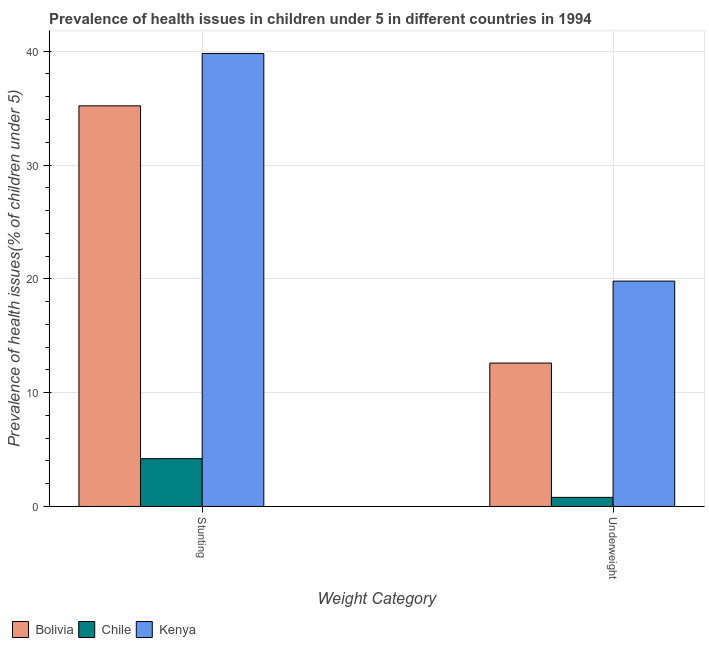How many different coloured bars are there?
Your answer should be compact. 3. How many groups of bars are there?
Give a very brief answer. 2. Are the number of bars per tick equal to the number of legend labels?
Your response must be concise. Yes. How many bars are there on the 2nd tick from the left?
Make the answer very short. 3. How many bars are there on the 2nd tick from the right?
Your response must be concise. 3. What is the label of the 1st group of bars from the left?
Provide a succinct answer. Stunting. What is the percentage of stunted children in Chile?
Keep it short and to the point. 4.2. Across all countries, what is the maximum percentage of stunted children?
Your answer should be very brief. 39.8. Across all countries, what is the minimum percentage of underweight children?
Make the answer very short. 0.8. In which country was the percentage of stunted children maximum?
Offer a very short reply. Kenya. What is the total percentage of underweight children in the graph?
Give a very brief answer. 33.2. What is the difference between the percentage of stunted children in Chile and that in Bolivia?
Keep it short and to the point. -31. What is the difference between the percentage of underweight children in Kenya and the percentage of stunted children in Chile?
Provide a succinct answer. 15.6. What is the average percentage of underweight children per country?
Give a very brief answer. 11.07. What is the difference between the percentage of stunted children and percentage of underweight children in Bolivia?
Ensure brevity in your answer.  22.6. In how many countries, is the percentage of stunted children greater than 28 %?
Make the answer very short. 2. What is the ratio of the percentage of stunted children in Kenya to that in Chile?
Your answer should be compact. 9.48. What does the 3rd bar from the left in Underweight represents?
Keep it short and to the point. Kenya. What is the difference between two consecutive major ticks on the Y-axis?
Keep it short and to the point. 10. Does the graph contain any zero values?
Your answer should be very brief. No. Does the graph contain grids?
Give a very brief answer. Yes. Where does the legend appear in the graph?
Provide a short and direct response. Bottom left. How many legend labels are there?
Your answer should be compact. 3. What is the title of the graph?
Your answer should be compact. Prevalence of health issues in children under 5 in different countries in 1994. What is the label or title of the X-axis?
Provide a short and direct response. Weight Category. What is the label or title of the Y-axis?
Give a very brief answer. Prevalence of health issues(% of children under 5). What is the Prevalence of health issues(% of children under 5) in Bolivia in Stunting?
Give a very brief answer. 35.2. What is the Prevalence of health issues(% of children under 5) of Chile in Stunting?
Offer a terse response. 4.2. What is the Prevalence of health issues(% of children under 5) in Kenya in Stunting?
Keep it short and to the point. 39.8. What is the Prevalence of health issues(% of children under 5) in Bolivia in Underweight?
Your answer should be very brief. 12.6. What is the Prevalence of health issues(% of children under 5) of Chile in Underweight?
Your response must be concise. 0.8. What is the Prevalence of health issues(% of children under 5) of Kenya in Underweight?
Your response must be concise. 19.8. Across all Weight Category, what is the maximum Prevalence of health issues(% of children under 5) of Bolivia?
Keep it short and to the point. 35.2. Across all Weight Category, what is the maximum Prevalence of health issues(% of children under 5) in Chile?
Your response must be concise. 4.2. Across all Weight Category, what is the maximum Prevalence of health issues(% of children under 5) of Kenya?
Ensure brevity in your answer.  39.8. Across all Weight Category, what is the minimum Prevalence of health issues(% of children under 5) of Bolivia?
Give a very brief answer. 12.6. Across all Weight Category, what is the minimum Prevalence of health issues(% of children under 5) in Chile?
Your answer should be compact. 0.8. Across all Weight Category, what is the minimum Prevalence of health issues(% of children under 5) of Kenya?
Keep it short and to the point. 19.8. What is the total Prevalence of health issues(% of children under 5) in Bolivia in the graph?
Offer a terse response. 47.8. What is the total Prevalence of health issues(% of children under 5) of Chile in the graph?
Provide a short and direct response. 5. What is the total Prevalence of health issues(% of children under 5) of Kenya in the graph?
Provide a succinct answer. 59.6. What is the difference between the Prevalence of health issues(% of children under 5) of Bolivia in Stunting and that in Underweight?
Give a very brief answer. 22.6. What is the difference between the Prevalence of health issues(% of children under 5) of Bolivia in Stunting and the Prevalence of health issues(% of children under 5) of Chile in Underweight?
Provide a succinct answer. 34.4. What is the difference between the Prevalence of health issues(% of children under 5) of Bolivia in Stunting and the Prevalence of health issues(% of children under 5) of Kenya in Underweight?
Offer a very short reply. 15.4. What is the difference between the Prevalence of health issues(% of children under 5) in Chile in Stunting and the Prevalence of health issues(% of children under 5) in Kenya in Underweight?
Your answer should be compact. -15.6. What is the average Prevalence of health issues(% of children under 5) in Bolivia per Weight Category?
Provide a short and direct response. 23.9. What is the average Prevalence of health issues(% of children under 5) of Kenya per Weight Category?
Offer a terse response. 29.8. What is the difference between the Prevalence of health issues(% of children under 5) in Chile and Prevalence of health issues(% of children under 5) in Kenya in Stunting?
Ensure brevity in your answer.  -35.6. What is the difference between the Prevalence of health issues(% of children under 5) of Bolivia and Prevalence of health issues(% of children under 5) of Chile in Underweight?
Make the answer very short. 11.8. What is the ratio of the Prevalence of health issues(% of children under 5) of Bolivia in Stunting to that in Underweight?
Keep it short and to the point. 2.79. What is the ratio of the Prevalence of health issues(% of children under 5) of Chile in Stunting to that in Underweight?
Offer a very short reply. 5.25. What is the ratio of the Prevalence of health issues(% of children under 5) in Kenya in Stunting to that in Underweight?
Provide a succinct answer. 2.01. What is the difference between the highest and the second highest Prevalence of health issues(% of children under 5) in Bolivia?
Your response must be concise. 22.6. What is the difference between the highest and the second highest Prevalence of health issues(% of children under 5) in Chile?
Your answer should be compact. 3.4. What is the difference between the highest and the second highest Prevalence of health issues(% of children under 5) in Kenya?
Your answer should be very brief. 20. What is the difference between the highest and the lowest Prevalence of health issues(% of children under 5) in Bolivia?
Give a very brief answer. 22.6. 